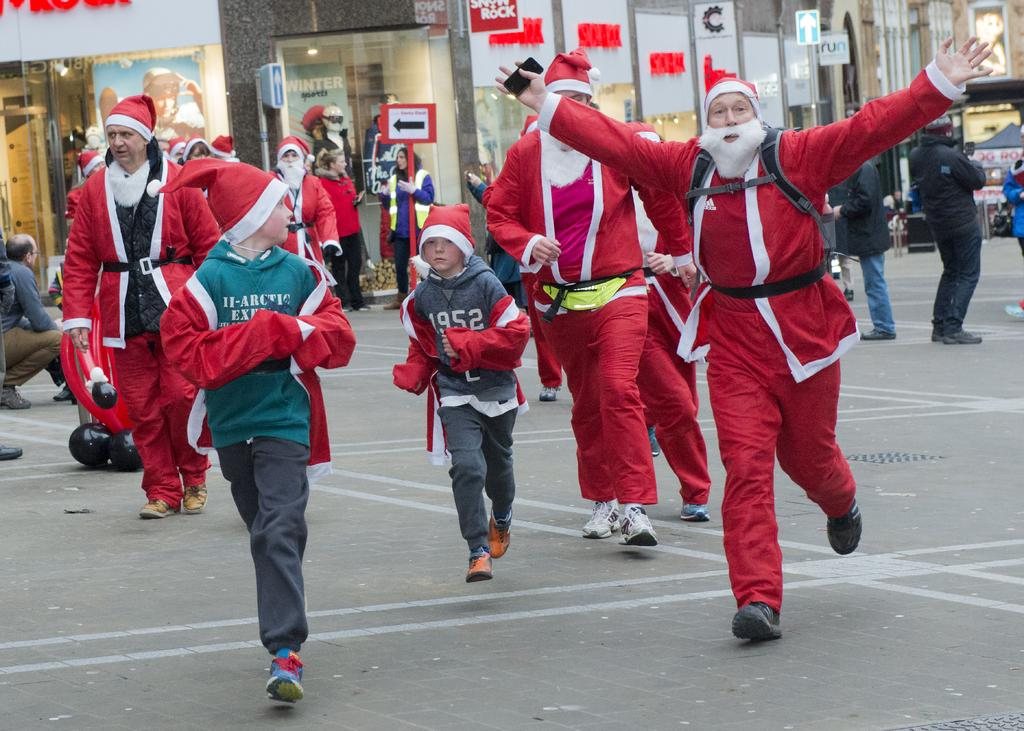What is happening on the road in the image? There are persons on the road in the image. What can be observed about the road's markings? The road has white color lines. What are some of the persons wearing? Some persons are wearing red color dresses. What can be seen in the background of the image? There are buildings in the background. What type of rock is being used as a prop in the image? There is no rock present in the image. What color is the underwear of the person wearing a red dress? The image does not show any underwear, so it cannot be determined. 